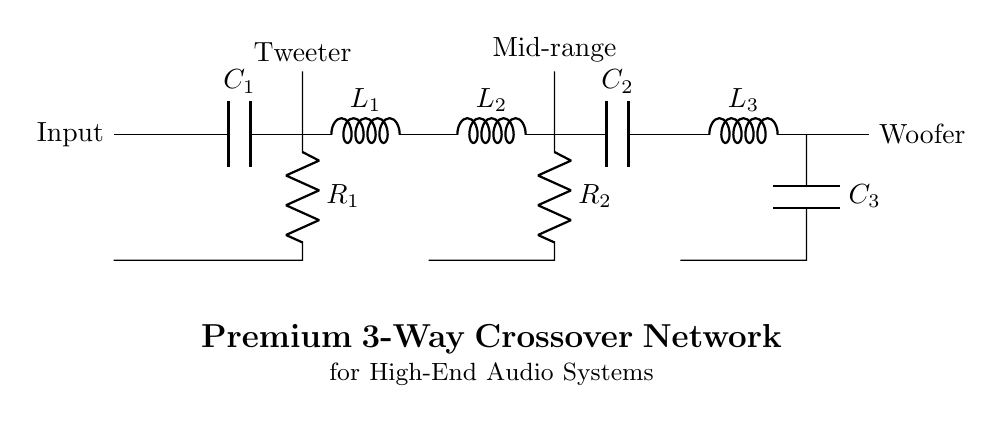What type of circuit is depicted here? The circuit is identified as a crossover network intended for audio applications, specifically a 3-way crossover involving high-pass, mid-range, and low-pass filters.
Answer: Crossover network How many capacitors are used in this circuit? By examining the diagram, there are three capacitors labeled as C1, C2, and C3 corresponding to different frequency ranges.
Answer: Three What is the component labeled R1 in this design? R1 acts as a resistor for the high-pass filter section, determining the frequency response along with the capacitor C1.
Answer: Resistor Which output is connected to the tweeter? The tweeter is connected to the output from the high-pass filter stage, which comprises the capacitor C1 and inductor L1 commonly designed to pass higher frequencies.
Answer: High-pass filter Explain how the mid-range filter is configured in this circuit. The mid-range filter consists of inductor L2 and capacitor C2 connected in series, which shapes the frequency response to allow mid-range frequencies to pass through while blocking others.
Answer: Inductor and capacitor in series What is the role of L3 in this circuit? L3 is an inductor in the low-pass filter section, which is designed to allow low frequencies to pass while blocking higher frequencies, thus sending them to the woofer.
Answer: Inductor for low-pass filter 